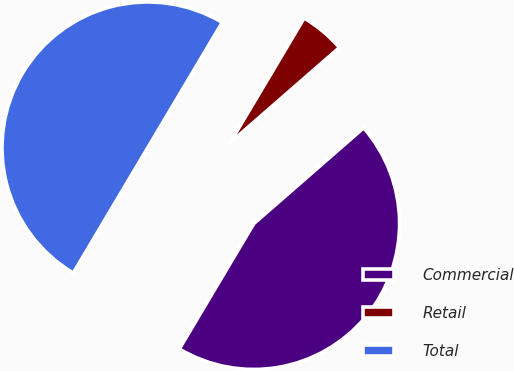Convert chart to OTSL. <chart><loc_0><loc_0><loc_500><loc_500><pie_chart><fcel>Commercial<fcel>Retail<fcel>Total<nl><fcel>44.95%<fcel>5.05%<fcel>50.0%<nl></chart> 